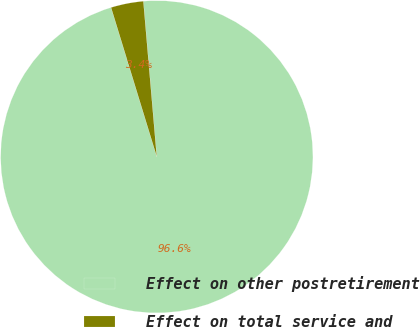Convert chart. <chart><loc_0><loc_0><loc_500><loc_500><pie_chart><fcel>Effect on other postretirement<fcel>Effect on total service and<nl><fcel>96.64%<fcel>3.36%<nl></chart> 